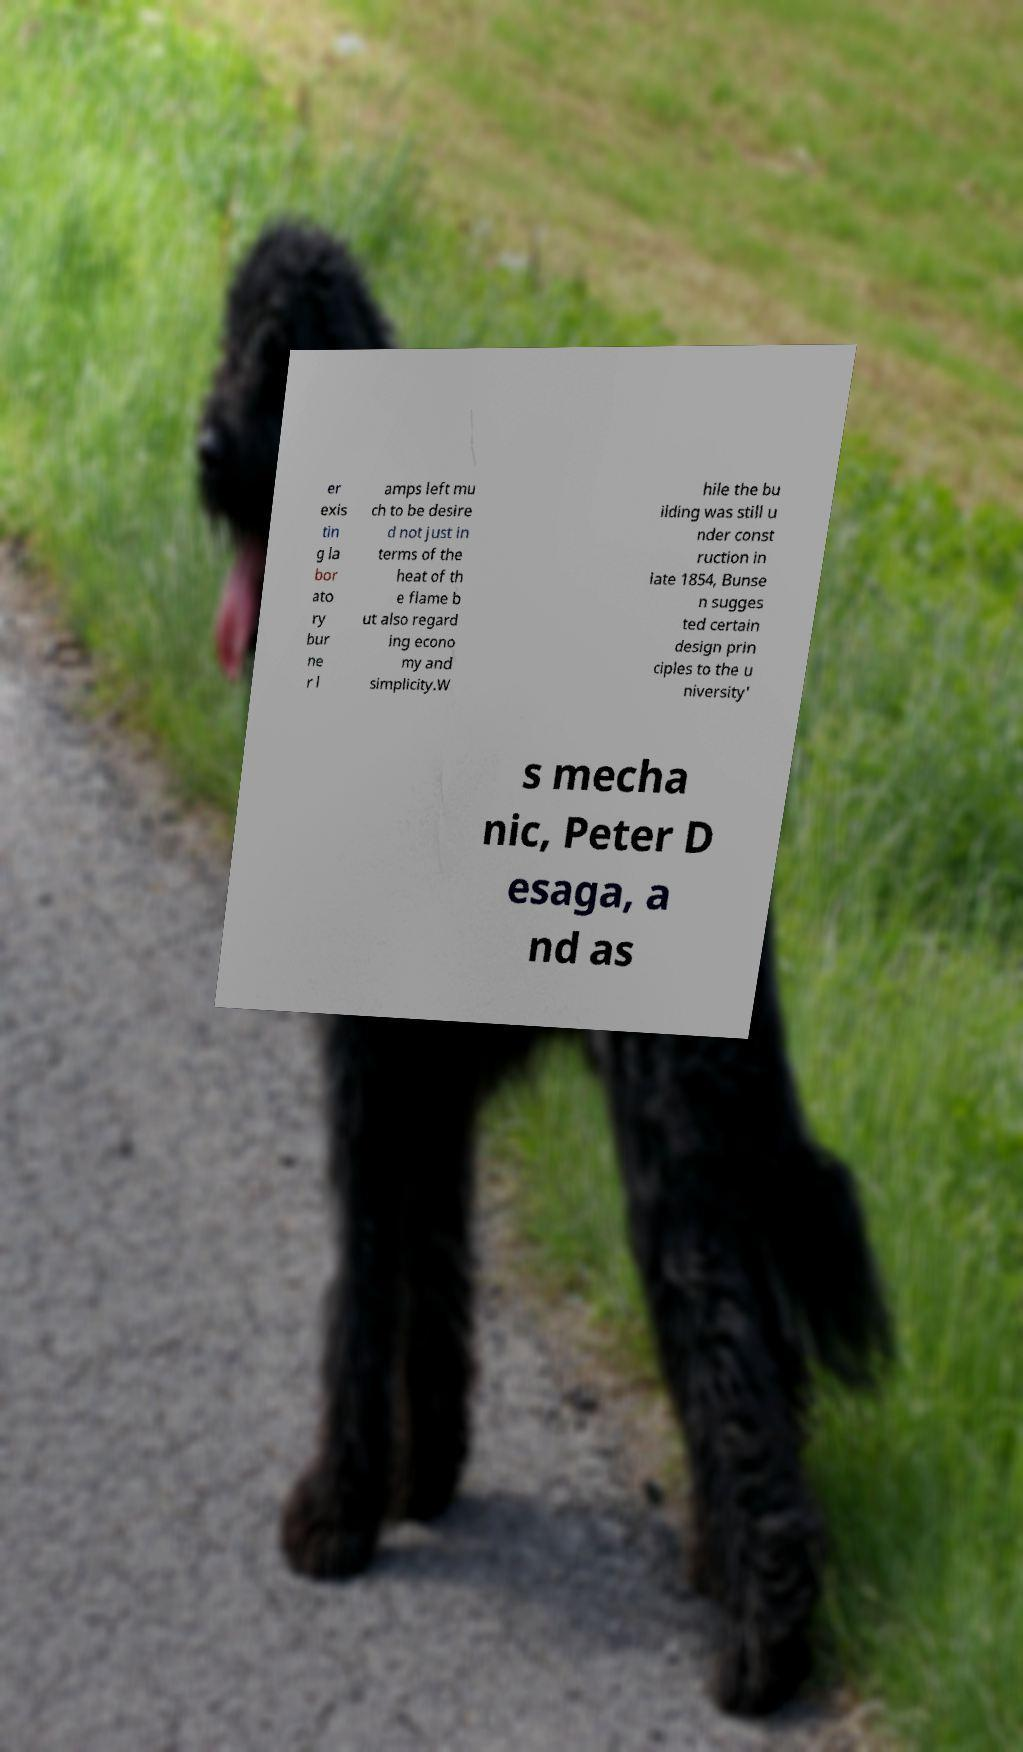Could you assist in decoding the text presented in this image and type it out clearly? er exis tin g la bor ato ry bur ne r l amps left mu ch to be desire d not just in terms of the heat of th e flame b ut also regard ing econo my and simplicity.W hile the bu ilding was still u nder const ruction in late 1854, Bunse n sugges ted certain design prin ciples to the u niversity' s mecha nic, Peter D esaga, a nd as 